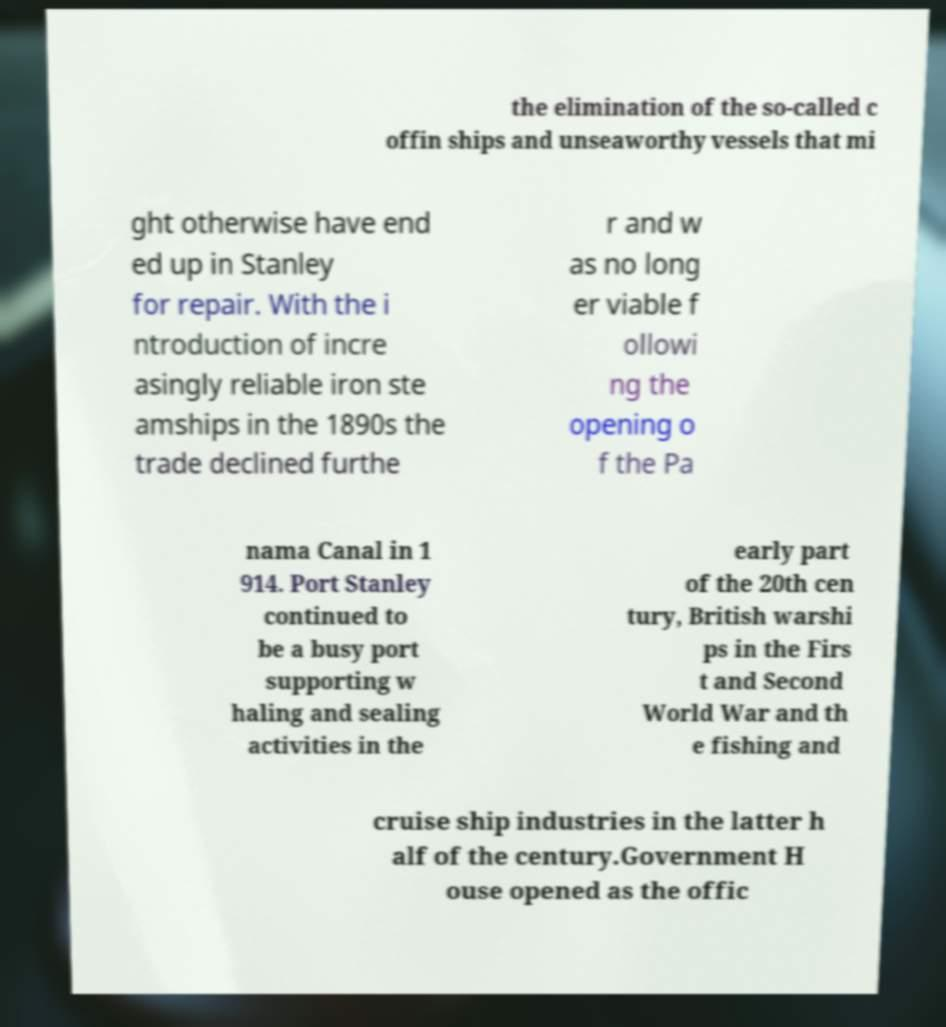Can you read and provide the text displayed in the image?This photo seems to have some interesting text. Can you extract and type it out for me? the elimination of the so-called c offin ships and unseaworthy vessels that mi ght otherwise have end ed up in Stanley for repair. With the i ntroduction of incre asingly reliable iron ste amships in the 1890s the trade declined furthe r and w as no long er viable f ollowi ng the opening o f the Pa nama Canal in 1 914. Port Stanley continued to be a busy port supporting w haling and sealing activities in the early part of the 20th cen tury, British warshi ps in the Firs t and Second World War and th e fishing and cruise ship industries in the latter h alf of the century.Government H ouse opened as the offic 